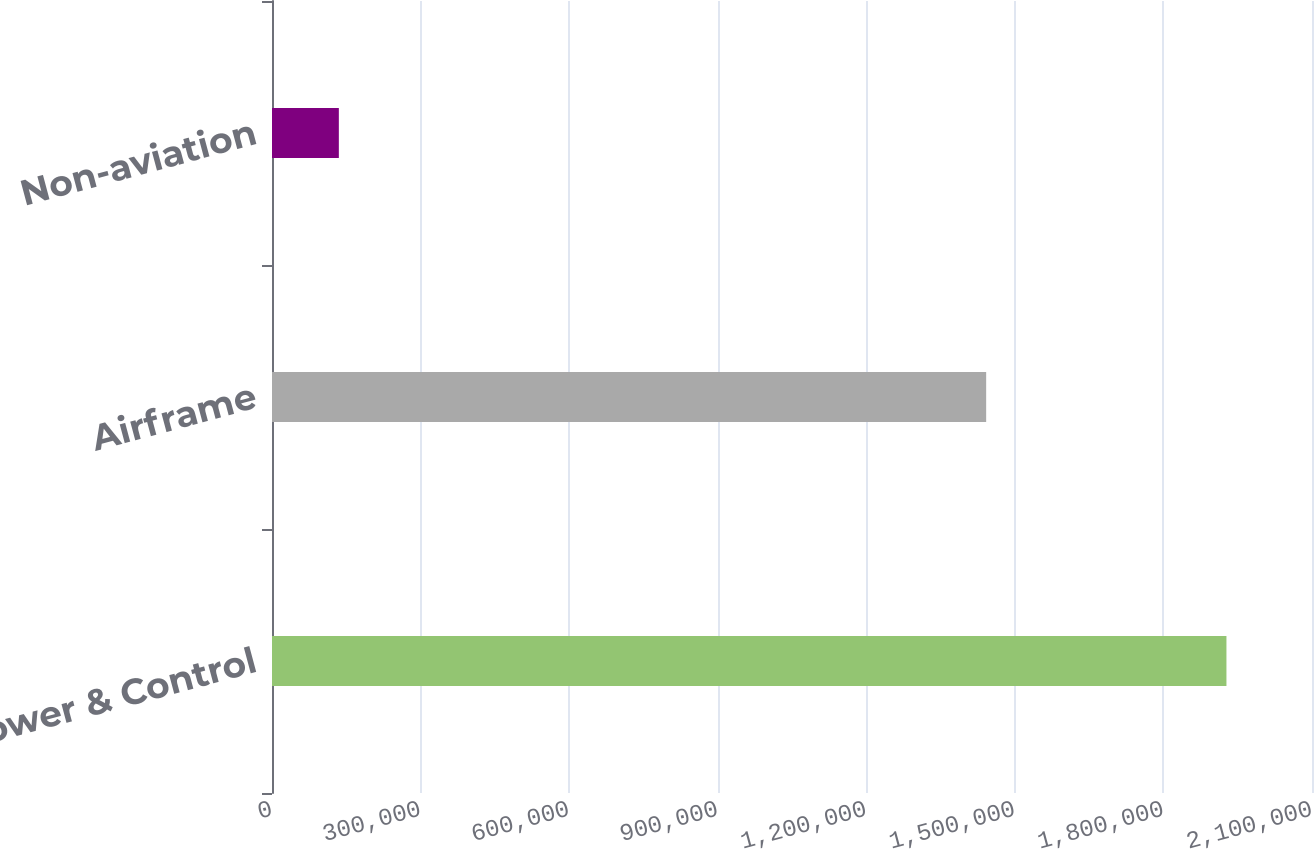<chart> <loc_0><loc_0><loc_500><loc_500><bar_chart><fcel>Power & Control<fcel>Airframe<fcel>Non-aviation<nl><fcel>1.92724e+06<fcel>1.44207e+06<fcel>134969<nl></chart> 